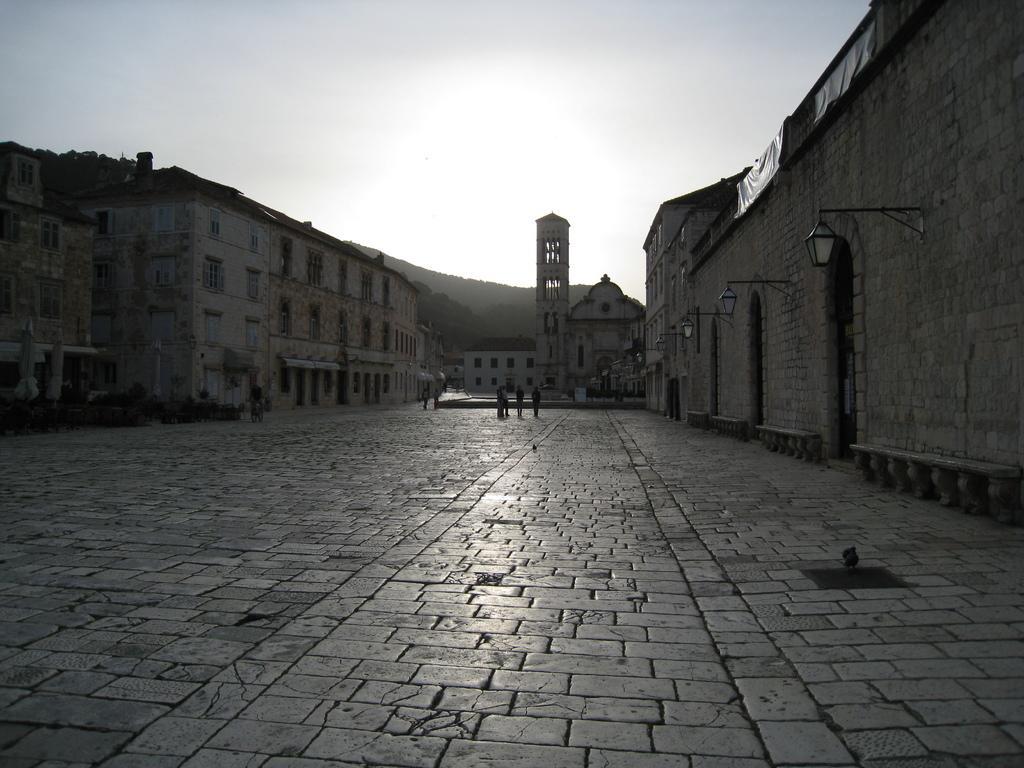Can you describe this image briefly? This picture shows few buildings and we see people walking and we see plants and few lights hanging to the wall and we see a cloudy sky and trees. 